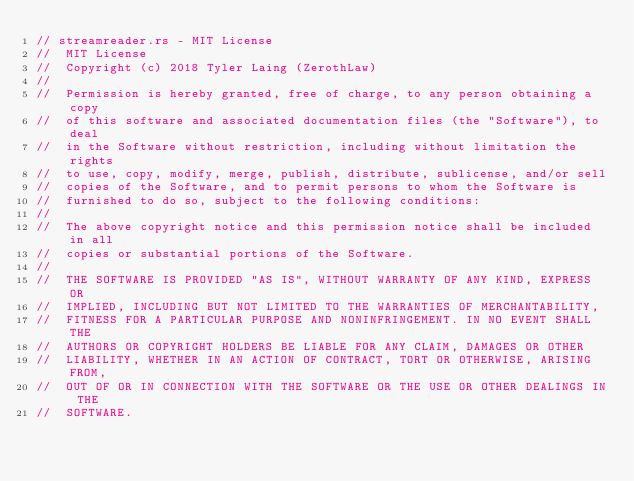<code> <loc_0><loc_0><loc_500><loc_500><_Rust_>// streamreader.rs - MIT License
//  MIT License
//  Copyright (c) 2018 Tyler Laing (ZerothLaw)
// 
//  Permission is hereby granted, free of charge, to any person obtaining a copy
//  of this software and associated documentation files (the "Software"), to deal
//  in the Software without restriction, including without limitation the rights
//  to use, copy, modify, merge, publish, distribute, sublicense, and/or sell
//  copies of the Software, and to permit persons to whom the Software is
//  furnished to do so, subject to the following conditions:
// 
//  The above copyright notice and this permission notice shall be included in all
//  copies or substantial portions of the Software.
// 
//  THE SOFTWARE IS PROVIDED "AS IS", WITHOUT WARRANTY OF ANY KIND, EXPRESS OR
//  IMPLIED, INCLUDING BUT NOT LIMITED TO THE WARRANTIES OF MERCHANTABILITY,
//  FITNESS FOR A PARTICULAR PURPOSE AND NONINFRINGEMENT. IN NO EVENT SHALL THE
//  AUTHORS OR COPYRIGHT HOLDERS BE LIABLE FOR ANY CLAIM, DAMAGES OR OTHER
//  LIABILITY, WHETHER IN AN ACTION OF CONTRACT, TORT OR OTHERWISE, ARISING FROM,
//  OUT OF OR IN CONNECTION WITH THE SOFTWARE OR THE USE OR OTHER DEALINGS IN THE
//  SOFTWARE.
</code> 